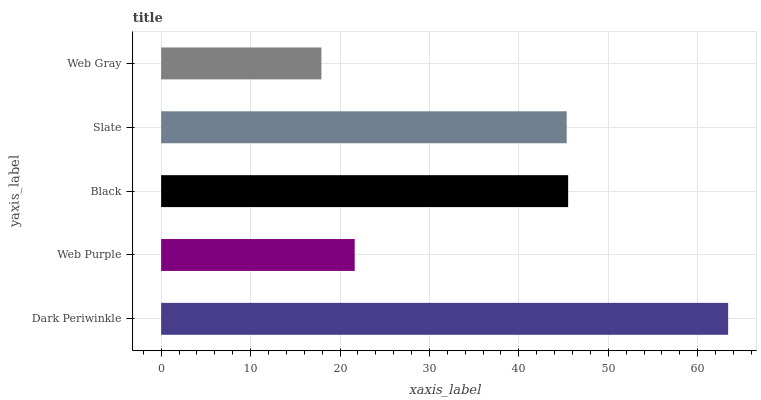Is Web Gray the minimum?
Answer yes or no. Yes. Is Dark Periwinkle the maximum?
Answer yes or no. Yes. Is Web Purple the minimum?
Answer yes or no. No. Is Web Purple the maximum?
Answer yes or no. No. Is Dark Periwinkle greater than Web Purple?
Answer yes or no. Yes. Is Web Purple less than Dark Periwinkle?
Answer yes or no. Yes. Is Web Purple greater than Dark Periwinkle?
Answer yes or no. No. Is Dark Periwinkle less than Web Purple?
Answer yes or no. No. Is Slate the high median?
Answer yes or no. Yes. Is Slate the low median?
Answer yes or no. Yes. Is Web Purple the high median?
Answer yes or no. No. Is Web Gray the low median?
Answer yes or no. No. 